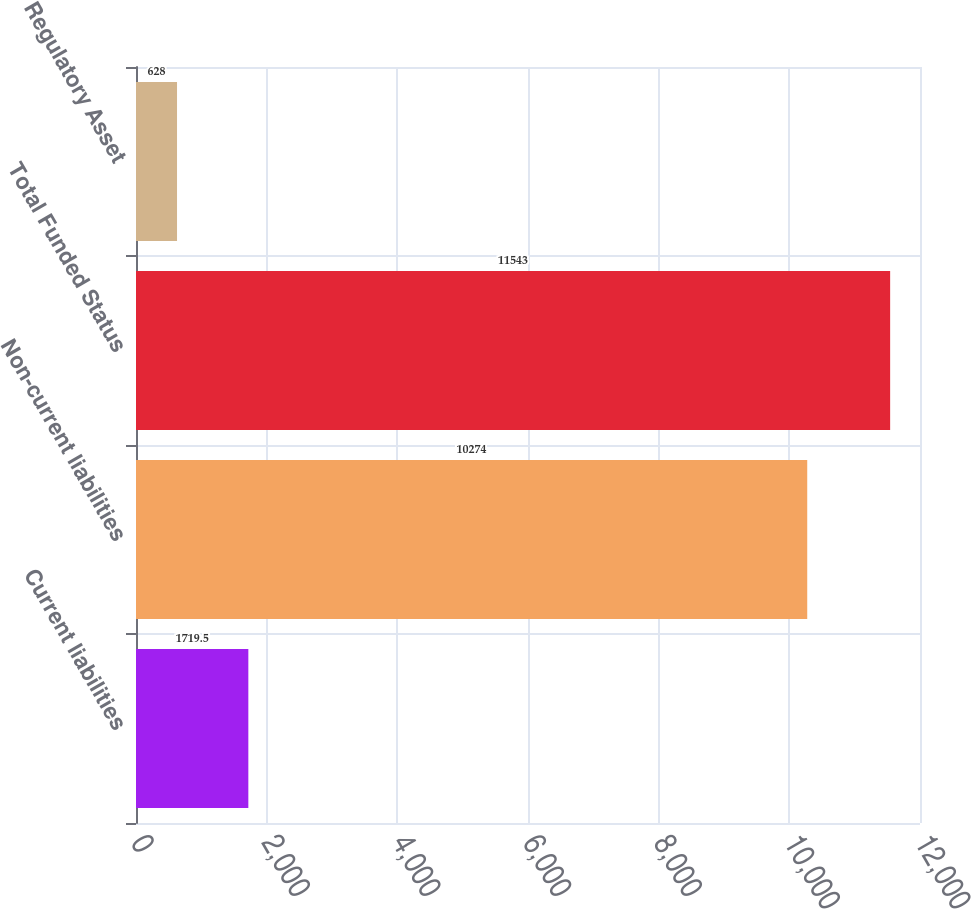Convert chart. <chart><loc_0><loc_0><loc_500><loc_500><bar_chart><fcel>Current liabilities<fcel>Non-current liabilities<fcel>Total Funded Status<fcel>Regulatory Asset<nl><fcel>1719.5<fcel>10274<fcel>11543<fcel>628<nl></chart> 